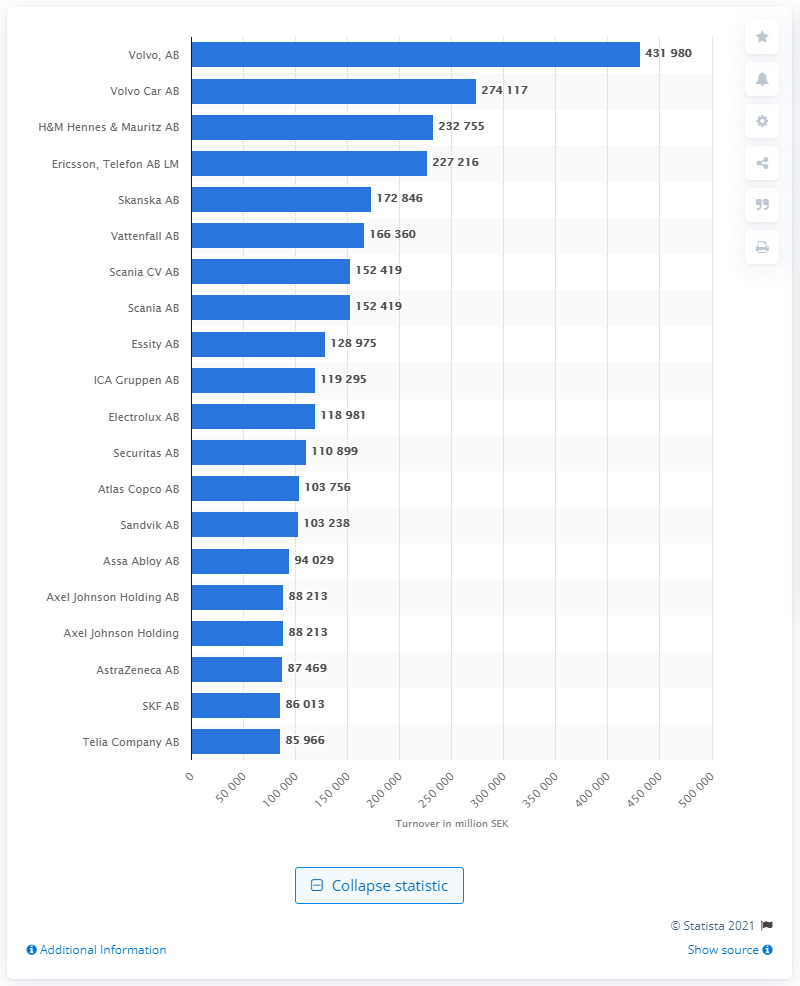Point out several critical features in this image. In 2020, Volvo AB's turnover was 431,980 Swedish kronor. 